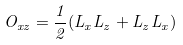<formula> <loc_0><loc_0><loc_500><loc_500>O _ { x z } = \frac { 1 } { 2 } ( L _ { x } L _ { z } + L _ { z } L _ { x } )</formula> 